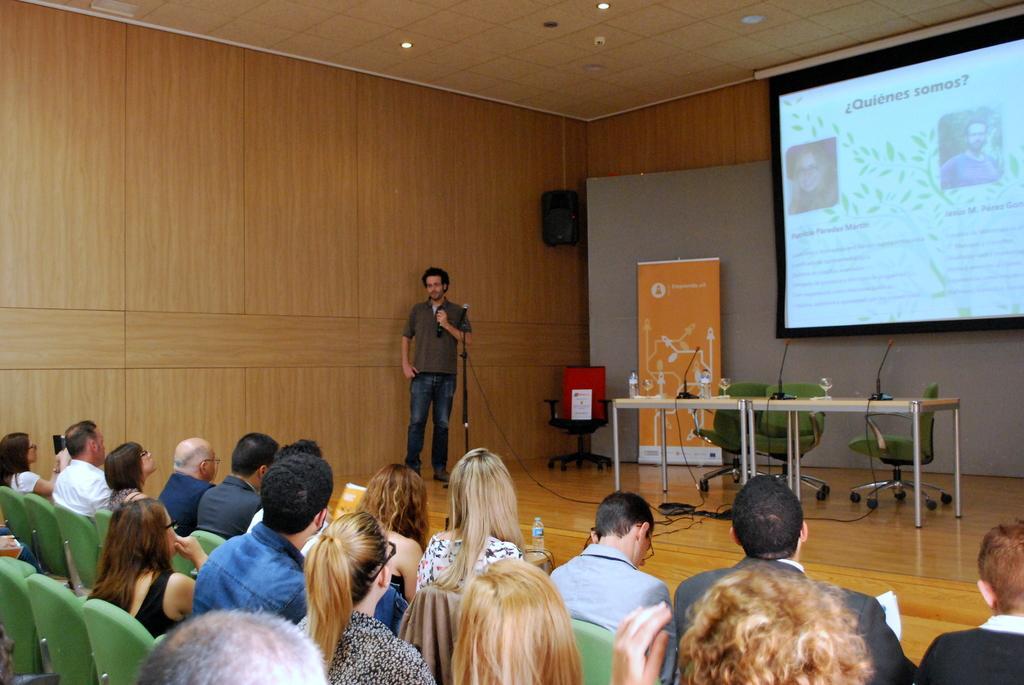Can you describe this image briefly? This image consists of many people. In the front, we can see a man standing and holding a mic. On the right, we can see a projector screen, banner, tables, chairs on the dais. At the bottom, there are many people sitting in the chairs. In the background, we can see a speaker on the wall. At the top, there is a roof. 